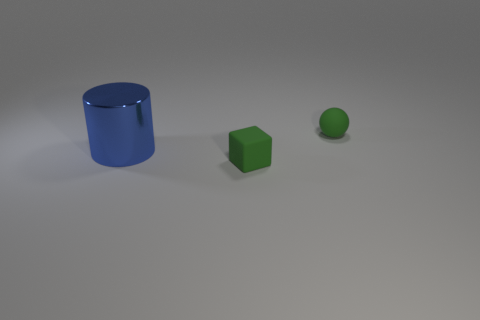What number of green matte objects are in front of the block?
Offer a very short reply. 0. Do the thing behind the big object and the small thing on the left side of the green ball have the same material?
Keep it short and to the point. Yes. There is a small sphere; does it have the same color as the rubber object that is on the left side of the small matte ball?
Make the answer very short. Yes. There is a object that is behind the block and to the right of the big blue thing; what shape is it?
Your answer should be compact. Sphere. How many large gray matte spheres are there?
Offer a very short reply. 0. The small rubber object that is the same color as the cube is what shape?
Provide a short and direct response. Sphere. The matte object that is in front of the sphere is what color?
Give a very brief answer. Green. How many other things are the same size as the green sphere?
Offer a very short reply. 1. Are there any other things that are the same shape as the large blue thing?
Make the answer very short. No. Is the number of big blue metal cylinders that are in front of the small green matte cube the same as the number of small yellow rubber objects?
Your answer should be compact. Yes. 